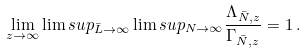<formula> <loc_0><loc_0><loc_500><loc_500>\lim _ { z \to \infty } \lim s u p _ { \bar { L } \to \infty } \lim s u p _ { N \to \infty } \frac { \Lambda _ { \bar { N } , z } } { \Gamma _ { \bar { N } , z } } = 1 \, .</formula> 